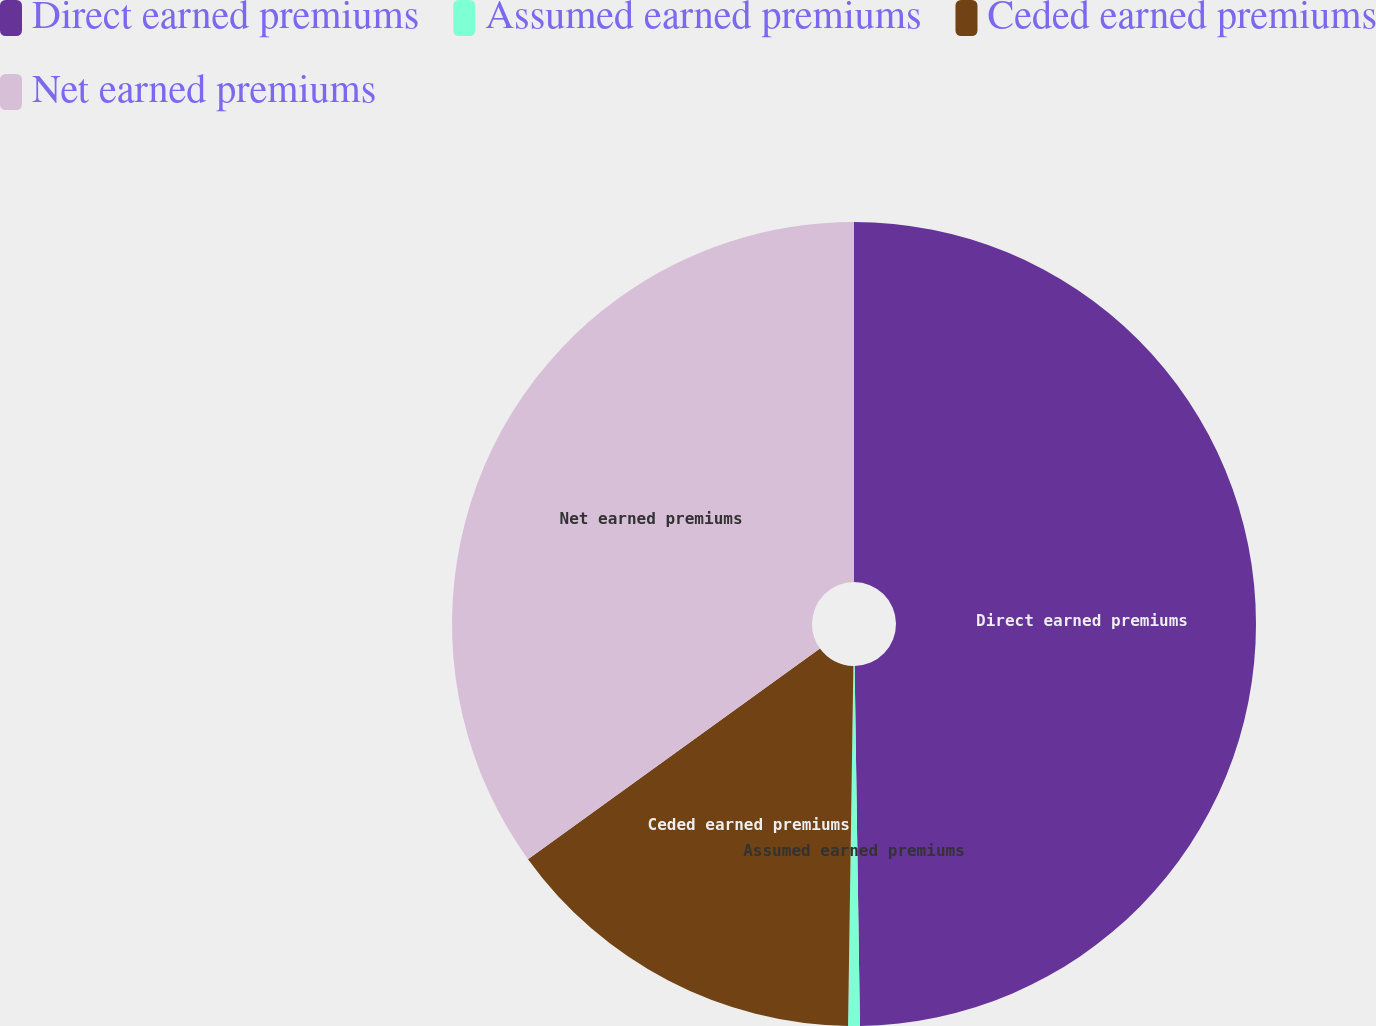Convert chart. <chart><loc_0><loc_0><loc_500><loc_500><pie_chart><fcel>Direct earned premiums<fcel>Assumed earned premiums<fcel>Ceded earned premiums<fcel>Net earned premiums<nl><fcel>49.77%<fcel>0.47%<fcel>14.82%<fcel>34.95%<nl></chart> 